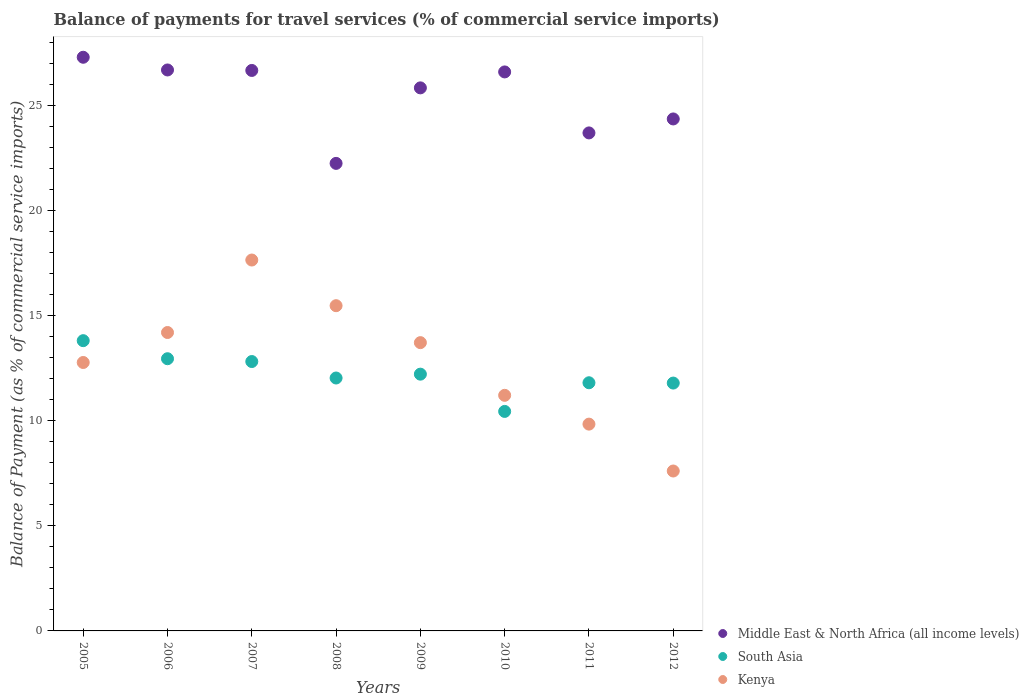What is the balance of payments for travel services in Kenya in 2011?
Offer a very short reply. 9.84. Across all years, what is the maximum balance of payments for travel services in Kenya?
Offer a terse response. 17.65. Across all years, what is the minimum balance of payments for travel services in South Asia?
Your response must be concise. 10.45. In which year was the balance of payments for travel services in South Asia minimum?
Give a very brief answer. 2010. What is the total balance of payments for travel services in Middle East & North Africa (all income levels) in the graph?
Offer a very short reply. 203.42. What is the difference between the balance of payments for travel services in Middle East & North Africa (all income levels) in 2005 and that in 2009?
Keep it short and to the point. 1.46. What is the difference between the balance of payments for travel services in Middle East & North Africa (all income levels) in 2008 and the balance of payments for travel services in South Asia in 2009?
Offer a very short reply. 10.03. What is the average balance of payments for travel services in Kenya per year?
Provide a short and direct response. 12.81. In the year 2010, what is the difference between the balance of payments for travel services in South Asia and balance of payments for travel services in Kenya?
Offer a terse response. -0.77. In how many years, is the balance of payments for travel services in South Asia greater than 4 %?
Keep it short and to the point. 8. What is the ratio of the balance of payments for travel services in South Asia in 2006 to that in 2012?
Your answer should be compact. 1.1. What is the difference between the highest and the second highest balance of payments for travel services in Kenya?
Give a very brief answer. 2.17. What is the difference between the highest and the lowest balance of payments for travel services in South Asia?
Your answer should be compact. 3.37. In how many years, is the balance of payments for travel services in Kenya greater than the average balance of payments for travel services in Kenya taken over all years?
Give a very brief answer. 4. Is it the case that in every year, the sum of the balance of payments for travel services in Middle East & North Africa (all income levels) and balance of payments for travel services in Kenya  is greater than the balance of payments for travel services in South Asia?
Your answer should be very brief. Yes. Is the balance of payments for travel services in Kenya strictly greater than the balance of payments for travel services in Middle East & North Africa (all income levels) over the years?
Offer a very short reply. No. What is the difference between two consecutive major ticks on the Y-axis?
Give a very brief answer. 5. Are the values on the major ticks of Y-axis written in scientific E-notation?
Offer a very short reply. No. Does the graph contain any zero values?
Your answer should be compact. No. How many legend labels are there?
Provide a succinct answer. 3. How are the legend labels stacked?
Provide a short and direct response. Vertical. What is the title of the graph?
Offer a terse response. Balance of payments for travel services (% of commercial service imports). What is the label or title of the Y-axis?
Ensure brevity in your answer.  Balance of Payment (as % of commercial service imports). What is the Balance of Payment (as % of commercial service imports) of Middle East & North Africa (all income levels) in 2005?
Your answer should be compact. 27.3. What is the Balance of Payment (as % of commercial service imports) of South Asia in 2005?
Your response must be concise. 13.81. What is the Balance of Payment (as % of commercial service imports) in Kenya in 2005?
Provide a short and direct response. 12.77. What is the Balance of Payment (as % of commercial service imports) of Middle East & North Africa (all income levels) in 2006?
Make the answer very short. 26.69. What is the Balance of Payment (as % of commercial service imports) of South Asia in 2006?
Your answer should be very brief. 12.95. What is the Balance of Payment (as % of commercial service imports) in Kenya in 2006?
Your answer should be very brief. 14.2. What is the Balance of Payment (as % of commercial service imports) in Middle East & North Africa (all income levels) in 2007?
Provide a short and direct response. 26.67. What is the Balance of Payment (as % of commercial service imports) of South Asia in 2007?
Provide a short and direct response. 12.82. What is the Balance of Payment (as % of commercial service imports) in Kenya in 2007?
Your answer should be very brief. 17.65. What is the Balance of Payment (as % of commercial service imports) in Middle East & North Africa (all income levels) in 2008?
Offer a terse response. 22.25. What is the Balance of Payment (as % of commercial service imports) in South Asia in 2008?
Your answer should be very brief. 12.04. What is the Balance of Payment (as % of commercial service imports) in Kenya in 2008?
Provide a succinct answer. 15.48. What is the Balance of Payment (as % of commercial service imports) of Middle East & North Africa (all income levels) in 2009?
Your response must be concise. 25.84. What is the Balance of Payment (as % of commercial service imports) of South Asia in 2009?
Keep it short and to the point. 12.22. What is the Balance of Payment (as % of commercial service imports) of Kenya in 2009?
Give a very brief answer. 13.72. What is the Balance of Payment (as % of commercial service imports) of Middle East & North Africa (all income levels) in 2010?
Provide a succinct answer. 26.6. What is the Balance of Payment (as % of commercial service imports) in South Asia in 2010?
Provide a short and direct response. 10.45. What is the Balance of Payment (as % of commercial service imports) in Kenya in 2010?
Offer a terse response. 11.21. What is the Balance of Payment (as % of commercial service imports) in Middle East & North Africa (all income levels) in 2011?
Keep it short and to the point. 23.7. What is the Balance of Payment (as % of commercial service imports) in South Asia in 2011?
Keep it short and to the point. 11.81. What is the Balance of Payment (as % of commercial service imports) in Kenya in 2011?
Give a very brief answer. 9.84. What is the Balance of Payment (as % of commercial service imports) in Middle East & North Africa (all income levels) in 2012?
Your answer should be compact. 24.36. What is the Balance of Payment (as % of commercial service imports) in South Asia in 2012?
Give a very brief answer. 11.79. What is the Balance of Payment (as % of commercial service imports) of Kenya in 2012?
Provide a succinct answer. 7.61. Across all years, what is the maximum Balance of Payment (as % of commercial service imports) of Middle East & North Africa (all income levels)?
Your response must be concise. 27.3. Across all years, what is the maximum Balance of Payment (as % of commercial service imports) in South Asia?
Your answer should be very brief. 13.81. Across all years, what is the maximum Balance of Payment (as % of commercial service imports) of Kenya?
Keep it short and to the point. 17.65. Across all years, what is the minimum Balance of Payment (as % of commercial service imports) in Middle East & North Africa (all income levels)?
Provide a short and direct response. 22.25. Across all years, what is the minimum Balance of Payment (as % of commercial service imports) in South Asia?
Ensure brevity in your answer.  10.45. Across all years, what is the minimum Balance of Payment (as % of commercial service imports) of Kenya?
Ensure brevity in your answer.  7.61. What is the total Balance of Payment (as % of commercial service imports) of Middle East & North Africa (all income levels) in the graph?
Your answer should be very brief. 203.42. What is the total Balance of Payment (as % of commercial service imports) of South Asia in the graph?
Offer a very short reply. 97.89. What is the total Balance of Payment (as % of commercial service imports) of Kenya in the graph?
Provide a short and direct response. 102.48. What is the difference between the Balance of Payment (as % of commercial service imports) in Middle East & North Africa (all income levels) in 2005 and that in 2006?
Offer a very short reply. 0.6. What is the difference between the Balance of Payment (as % of commercial service imports) of South Asia in 2005 and that in 2006?
Provide a succinct answer. 0.86. What is the difference between the Balance of Payment (as % of commercial service imports) of Kenya in 2005 and that in 2006?
Give a very brief answer. -1.43. What is the difference between the Balance of Payment (as % of commercial service imports) of Middle East & North Africa (all income levels) in 2005 and that in 2007?
Offer a very short reply. 0.63. What is the difference between the Balance of Payment (as % of commercial service imports) in South Asia in 2005 and that in 2007?
Provide a succinct answer. 0.99. What is the difference between the Balance of Payment (as % of commercial service imports) of Kenya in 2005 and that in 2007?
Provide a short and direct response. -4.88. What is the difference between the Balance of Payment (as % of commercial service imports) of Middle East & North Africa (all income levels) in 2005 and that in 2008?
Provide a succinct answer. 5.05. What is the difference between the Balance of Payment (as % of commercial service imports) in South Asia in 2005 and that in 2008?
Ensure brevity in your answer.  1.78. What is the difference between the Balance of Payment (as % of commercial service imports) of Kenya in 2005 and that in 2008?
Offer a terse response. -2.7. What is the difference between the Balance of Payment (as % of commercial service imports) in Middle East & North Africa (all income levels) in 2005 and that in 2009?
Offer a very short reply. 1.46. What is the difference between the Balance of Payment (as % of commercial service imports) in South Asia in 2005 and that in 2009?
Provide a short and direct response. 1.59. What is the difference between the Balance of Payment (as % of commercial service imports) in Kenya in 2005 and that in 2009?
Ensure brevity in your answer.  -0.94. What is the difference between the Balance of Payment (as % of commercial service imports) of Middle East & North Africa (all income levels) in 2005 and that in 2010?
Provide a succinct answer. 0.7. What is the difference between the Balance of Payment (as % of commercial service imports) of South Asia in 2005 and that in 2010?
Provide a succinct answer. 3.37. What is the difference between the Balance of Payment (as % of commercial service imports) of Kenya in 2005 and that in 2010?
Provide a short and direct response. 1.56. What is the difference between the Balance of Payment (as % of commercial service imports) in Middle East & North Africa (all income levels) in 2005 and that in 2011?
Keep it short and to the point. 3.6. What is the difference between the Balance of Payment (as % of commercial service imports) of South Asia in 2005 and that in 2011?
Ensure brevity in your answer.  2. What is the difference between the Balance of Payment (as % of commercial service imports) in Kenya in 2005 and that in 2011?
Ensure brevity in your answer.  2.93. What is the difference between the Balance of Payment (as % of commercial service imports) of Middle East & North Africa (all income levels) in 2005 and that in 2012?
Offer a very short reply. 2.94. What is the difference between the Balance of Payment (as % of commercial service imports) in South Asia in 2005 and that in 2012?
Give a very brief answer. 2.02. What is the difference between the Balance of Payment (as % of commercial service imports) of Kenya in 2005 and that in 2012?
Your answer should be very brief. 5.16. What is the difference between the Balance of Payment (as % of commercial service imports) in Middle East & North Africa (all income levels) in 2006 and that in 2007?
Provide a short and direct response. 0.02. What is the difference between the Balance of Payment (as % of commercial service imports) in South Asia in 2006 and that in 2007?
Your answer should be very brief. 0.13. What is the difference between the Balance of Payment (as % of commercial service imports) in Kenya in 2006 and that in 2007?
Your response must be concise. -3.45. What is the difference between the Balance of Payment (as % of commercial service imports) of Middle East & North Africa (all income levels) in 2006 and that in 2008?
Make the answer very short. 4.45. What is the difference between the Balance of Payment (as % of commercial service imports) in South Asia in 2006 and that in 2008?
Offer a terse response. 0.92. What is the difference between the Balance of Payment (as % of commercial service imports) in Kenya in 2006 and that in 2008?
Your response must be concise. -1.28. What is the difference between the Balance of Payment (as % of commercial service imports) of Middle East & North Africa (all income levels) in 2006 and that in 2009?
Your answer should be compact. 0.85. What is the difference between the Balance of Payment (as % of commercial service imports) of South Asia in 2006 and that in 2009?
Give a very brief answer. 0.73. What is the difference between the Balance of Payment (as % of commercial service imports) in Kenya in 2006 and that in 2009?
Keep it short and to the point. 0.48. What is the difference between the Balance of Payment (as % of commercial service imports) in Middle East & North Africa (all income levels) in 2006 and that in 2010?
Your response must be concise. 0.09. What is the difference between the Balance of Payment (as % of commercial service imports) in South Asia in 2006 and that in 2010?
Your answer should be compact. 2.51. What is the difference between the Balance of Payment (as % of commercial service imports) in Kenya in 2006 and that in 2010?
Offer a very short reply. 2.99. What is the difference between the Balance of Payment (as % of commercial service imports) in Middle East & North Africa (all income levels) in 2006 and that in 2011?
Your answer should be compact. 3. What is the difference between the Balance of Payment (as % of commercial service imports) of South Asia in 2006 and that in 2011?
Keep it short and to the point. 1.14. What is the difference between the Balance of Payment (as % of commercial service imports) in Kenya in 2006 and that in 2011?
Make the answer very short. 4.36. What is the difference between the Balance of Payment (as % of commercial service imports) of Middle East & North Africa (all income levels) in 2006 and that in 2012?
Give a very brief answer. 2.33. What is the difference between the Balance of Payment (as % of commercial service imports) of South Asia in 2006 and that in 2012?
Offer a very short reply. 1.16. What is the difference between the Balance of Payment (as % of commercial service imports) in Kenya in 2006 and that in 2012?
Offer a terse response. 6.59. What is the difference between the Balance of Payment (as % of commercial service imports) in Middle East & North Africa (all income levels) in 2007 and that in 2008?
Your answer should be compact. 4.42. What is the difference between the Balance of Payment (as % of commercial service imports) of South Asia in 2007 and that in 2008?
Your answer should be compact. 0.78. What is the difference between the Balance of Payment (as % of commercial service imports) of Kenya in 2007 and that in 2008?
Provide a short and direct response. 2.17. What is the difference between the Balance of Payment (as % of commercial service imports) in Middle East & North Africa (all income levels) in 2007 and that in 2009?
Your response must be concise. 0.83. What is the difference between the Balance of Payment (as % of commercial service imports) of South Asia in 2007 and that in 2009?
Give a very brief answer. 0.6. What is the difference between the Balance of Payment (as % of commercial service imports) in Kenya in 2007 and that in 2009?
Your answer should be compact. 3.93. What is the difference between the Balance of Payment (as % of commercial service imports) of Middle East & North Africa (all income levels) in 2007 and that in 2010?
Your answer should be compact. 0.07. What is the difference between the Balance of Payment (as % of commercial service imports) in South Asia in 2007 and that in 2010?
Give a very brief answer. 2.37. What is the difference between the Balance of Payment (as % of commercial service imports) of Kenya in 2007 and that in 2010?
Keep it short and to the point. 6.44. What is the difference between the Balance of Payment (as % of commercial service imports) of Middle East & North Africa (all income levels) in 2007 and that in 2011?
Your answer should be compact. 2.97. What is the difference between the Balance of Payment (as % of commercial service imports) in South Asia in 2007 and that in 2011?
Ensure brevity in your answer.  1.01. What is the difference between the Balance of Payment (as % of commercial service imports) of Kenya in 2007 and that in 2011?
Provide a short and direct response. 7.81. What is the difference between the Balance of Payment (as % of commercial service imports) in Middle East & North Africa (all income levels) in 2007 and that in 2012?
Ensure brevity in your answer.  2.31. What is the difference between the Balance of Payment (as % of commercial service imports) in South Asia in 2007 and that in 2012?
Ensure brevity in your answer.  1.02. What is the difference between the Balance of Payment (as % of commercial service imports) of Kenya in 2007 and that in 2012?
Give a very brief answer. 10.04. What is the difference between the Balance of Payment (as % of commercial service imports) in Middle East & North Africa (all income levels) in 2008 and that in 2009?
Provide a short and direct response. -3.59. What is the difference between the Balance of Payment (as % of commercial service imports) of South Asia in 2008 and that in 2009?
Give a very brief answer. -0.18. What is the difference between the Balance of Payment (as % of commercial service imports) in Kenya in 2008 and that in 2009?
Your response must be concise. 1.76. What is the difference between the Balance of Payment (as % of commercial service imports) of Middle East & North Africa (all income levels) in 2008 and that in 2010?
Ensure brevity in your answer.  -4.35. What is the difference between the Balance of Payment (as % of commercial service imports) in South Asia in 2008 and that in 2010?
Keep it short and to the point. 1.59. What is the difference between the Balance of Payment (as % of commercial service imports) in Kenya in 2008 and that in 2010?
Provide a short and direct response. 4.27. What is the difference between the Balance of Payment (as % of commercial service imports) in Middle East & North Africa (all income levels) in 2008 and that in 2011?
Offer a terse response. -1.45. What is the difference between the Balance of Payment (as % of commercial service imports) of South Asia in 2008 and that in 2011?
Ensure brevity in your answer.  0.23. What is the difference between the Balance of Payment (as % of commercial service imports) of Kenya in 2008 and that in 2011?
Your answer should be very brief. 5.64. What is the difference between the Balance of Payment (as % of commercial service imports) in Middle East & North Africa (all income levels) in 2008 and that in 2012?
Provide a succinct answer. -2.11. What is the difference between the Balance of Payment (as % of commercial service imports) in South Asia in 2008 and that in 2012?
Offer a terse response. 0.24. What is the difference between the Balance of Payment (as % of commercial service imports) of Kenya in 2008 and that in 2012?
Offer a terse response. 7.87. What is the difference between the Balance of Payment (as % of commercial service imports) in Middle East & North Africa (all income levels) in 2009 and that in 2010?
Make the answer very short. -0.76. What is the difference between the Balance of Payment (as % of commercial service imports) of South Asia in 2009 and that in 2010?
Your answer should be very brief. 1.77. What is the difference between the Balance of Payment (as % of commercial service imports) in Kenya in 2009 and that in 2010?
Provide a succinct answer. 2.51. What is the difference between the Balance of Payment (as % of commercial service imports) in Middle East & North Africa (all income levels) in 2009 and that in 2011?
Make the answer very short. 2.14. What is the difference between the Balance of Payment (as % of commercial service imports) in South Asia in 2009 and that in 2011?
Provide a succinct answer. 0.41. What is the difference between the Balance of Payment (as % of commercial service imports) in Kenya in 2009 and that in 2011?
Ensure brevity in your answer.  3.88. What is the difference between the Balance of Payment (as % of commercial service imports) in Middle East & North Africa (all income levels) in 2009 and that in 2012?
Keep it short and to the point. 1.48. What is the difference between the Balance of Payment (as % of commercial service imports) in South Asia in 2009 and that in 2012?
Ensure brevity in your answer.  0.42. What is the difference between the Balance of Payment (as % of commercial service imports) of Kenya in 2009 and that in 2012?
Your response must be concise. 6.11. What is the difference between the Balance of Payment (as % of commercial service imports) in Middle East & North Africa (all income levels) in 2010 and that in 2011?
Provide a succinct answer. 2.9. What is the difference between the Balance of Payment (as % of commercial service imports) in South Asia in 2010 and that in 2011?
Offer a very short reply. -1.36. What is the difference between the Balance of Payment (as % of commercial service imports) in Kenya in 2010 and that in 2011?
Your answer should be very brief. 1.37. What is the difference between the Balance of Payment (as % of commercial service imports) of Middle East & North Africa (all income levels) in 2010 and that in 2012?
Keep it short and to the point. 2.24. What is the difference between the Balance of Payment (as % of commercial service imports) of South Asia in 2010 and that in 2012?
Ensure brevity in your answer.  -1.35. What is the difference between the Balance of Payment (as % of commercial service imports) in Kenya in 2010 and that in 2012?
Your response must be concise. 3.6. What is the difference between the Balance of Payment (as % of commercial service imports) in Middle East & North Africa (all income levels) in 2011 and that in 2012?
Provide a short and direct response. -0.66. What is the difference between the Balance of Payment (as % of commercial service imports) of South Asia in 2011 and that in 2012?
Your answer should be compact. 0.01. What is the difference between the Balance of Payment (as % of commercial service imports) of Kenya in 2011 and that in 2012?
Your answer should be compact. 2.23. What is the difference between the Balance of Payment (as % of commercial service imports) of Middle East & North Africa (all income levels) in 2005 and the Balance of Payment (as % of commercial service imports) of South Asia in 2006?
Offer a very short reply. 14.35. What is the difference between the Balance of Payment (as % of commercial service imports) of Middle East & North Africa (all income levels) in 2005 and the Balance of Payment (as % of commercial service imports) of Kenya in 2006?
Your answer should be compact. 13.1. What is the difference between the Balance of Payment (as % of commercial service imports) in South Asia in 2005 and the Balance of Payment (as % of commercial service imports) in Kenya in 2006?
Ensure brevity in your answer.  -0.39. What is the difference between the Balance of Payment (as % of commercial service imports) in Middle East & North Africa (all income levels) in 2005 and the Balance of Payment (as % of commercial service imports) in South Asia in 2007?
Ensure brevity in your answer.  14.48. What is the difference between the Balance of Payment (as % of commercial service imports) in Middle East & North Africa (all income levels) in 2005 and the Balance of Payment (as % of commercial service imports) in Kenya in 2007?
Your response must be concise. 9.65. What is the difference between the Balance of Payment (as % of commercial service imports) in South Asia in 2005 and the Balance of Payment (as % of commercial service imports) in Kenya in 2007?
Provide a succinct answer. -3.84. What is the difference between the Balance of Payment (as % of commercial service imports) of Middle East & North Africa (all income levels) in 2005 and the Balance of Payment (as % of commercial service imports) of South Asia in 2008?
Give a very brief answer. 15.26. What is the difference between the Balance of Payment (as % of commercial service imports) in Middle East & North Africa (all income levels) in 2005 and the Balance of Payment (as % of commercial service imports) in Kenya in 2008?
Provide a succinct answer. 11.82. What is the difference between the Balance of Payment (as % of commercial service imports) in South Asia in 2005 and the Balance of Payment (as % of commercial service imports) in Kenya in 2008?
Provide a short and direct response. -1.66. What is the difference between the Balance of Payment (as % of commercial service imports) in Middle East & North Africa (all income levels) in 2005 and the Balance of Payment (as % of commercial service imports) in South Asia in 2009?
Give a very brief answer. 15.08. What is the difference between the Balance of Payment (as % of commercial service imports) in Middle East & North Africa (all income levels) in 2005 and the Balance of Payment (as % of commercial service imports) in Kenya in 2009?
Your response must be concise. 13.58. What is the difference between the Balance of Payment (as % of commercial service imports) in South Asia in 2005 and the Balance of Payment (as % of commercial service imports) in Kenya in 2009?
Offer a terse response. 0.09. What is the difference between the Balance of Payment (as % of commercial service imports) in Middle East & North Africa (all income levels) in 2005 and the Balance of Payment (as % of commercial service imports) in South Asia in 2010?
Provide a succinct answer. 16.85. What is the difference between the Balance of Payment (as % of commercial service imports) in Middle East & North Africa (all income levels) in 2005 and the Balance of Payment (as % of commercial service imports) in Kenya in 2010?
Your response must be concise. 16.09. What is the difference between the Balance of Payment (as % of commercial service imports) of South Asia in 2005 and the Balance of Payment (as % of commercial service imports) of Kenya in 2010?
Your answer should be very brief. 2.6. What is the difference between the Balance of Payment (as % of commercial service imports) of Middle East & North Africa (all income levels) in 2005 and the Balance of Payment (as % of commercial service imports) of South Asia in 2011?
Make the answer very short. 15.49. What is the difference between the Balance of Payment (as % of commercial service imports) in Middle East & North Africa (all income levels) in 2005 and the Balance of Payment (as % of commercial service imports) in Kenya in 2011?
Give a very brief answer. 17.46. What is the difference between the Balance of Payment (as % of commercial service imports) in South Asia in 2005 and the Balance of Payment (as % of commercial service imports) in Kenya in 2011?
Provide a succinct answer. 3.97. What is the difference between the Balance of Payment (as % of commercial service imports) in Middle East & North Africa (all income levels) in 2005 and the Balance of Payment (as % of commercial service imports) in South Asia in 2012?
Offer a terse response. 15.5. What is the difference between the Balance of Payment (as % of commercial service imports) of Middle East & North Africa (all income levels) in 2005 and the Balance of Payment (as % of commercial service imports) of Kenya in 2012?
Provide a short and direct response. 19.69. What is the difference between the Balance of Payment (as % of commercial service imports) of South Asia in 2005 and the Balance of Payment (as % of commercial service imports) of Kenya in 2012?
Keep it short and to the point. 6.2. What is the difference between the Balance of Payment (as % of commercial service imports) in Middle East & North Africa (all income levels) in 2006 and the Balance of Payment (as % of commercial service imports) in South Asia in 2007?
Provide a succinct answer. 13.88. What is the difference between the Balance of Payment (as % of commercial service imports) of Middle East & North Africa (all income levels) in 2006 and the Balance of Payment (as % of commercial service imports) of Kenya in 2007?
Ensure brevity in your answer.  9.04. What is the difference between the Balance of Payment (as % of commercial service imports) of South Asia in 2006 and the Balance of Payment (as % of commercial service imports) of Kenya in 2007?
Provide a short and direct response. -4.7. What is the difference between the Balance of Payment (as % of commercial service imports) of Middle East & North Africa (all income levels) in 2006 and the Balance of Payment (as % of commercial service imports) of South Asia in 2008?
Make the answer very short. 14.66. What is the difference between the Balance of Payment (as % of commercial service imports) in Middle East & North Africa (all income levels) in 2006 and the Balance of Payment (as % of commercial service imports) in Kenya in 2008?
Provide a succinct answer. 11.22. What is the difference between the Balance of Payment (as % of commercial service imports) of South Asia in 2006 and the Balance of Payment (as % of commercial service imports) of Kenya in 2008?
Give a very brief answer. -2.52. What is the difference between the Balance of Payment (as % of commercial service imports) of Middle East & North Africa (all income levels) in 2006 and the Balance of Payment (as % of commercial service imports) of South Asia in 2009?
Offer a terse response. 14.48. What is the difference between the Balance of Payment (as % of commercial service imports) in Middle East & North Africa (all income levels) in 2006 and the Balance of Payment (as % of commercial service imports) in Kenya in 2009?
Your answer should be very brief. 12.98. What is the difference between the Balance of Payment (as % of commercial service imports) of South Asia in 2006 and the Balance of Payment (as % of commercial service imports) of Kenya in 2009?
Offer a terse response. -0.77. What is the difference between the Balance of Payment (as % of commercial service imports) of Middle East & North Africa (all income levels) in 2006 and the Balance of Payment (as % of commercial service imports) of South Asia in 2010?
Make the answer very short. 16.25. What is the difference between the Balance of Payment (as % of commercial service imports) in Middle East & North Africa (all income levels) in 2006 and the Balance of Payment (as % of commercial service imports) in Kenya in 2010?
Offer a very short reply. 15.48. What is the difference between the Balance of Payment (as % of commercial service imports) in South Asia in 2006 and the Balance of Payment (as % of commercial service imports) in Kenya in 2010?
Make the answer very short. 1.74. What is the difference between the Balance of Payment (as % of commercial service imports) in Middle East & North Africa (all income levels) in 2006 and the Balance of Payment (as % of commercial service imports) in South Asia in 2011?
Offer a terse response. 14.88. What is the difference between the Balance of Payment (as % of commercial service imports) of Middle East & North Africa (all income levels) in 2006 and the Balance of Payment (as % of commercial service imports) of Kenya in 2011?
Your answer should be very brief. 16.85. What is the difference between the Balance of Payment (as % of commercial service imports) in South Asia in 2006 and the Balance of Payment (as % of commercial service imports) in Kenya in 2011?
Your response must be concise. 3.11. What is the difference between the Balance of Payment (as % of commercial service imports) of Middle East & North Africa (all income levels) in 2006 and the Balance of Payment (as % of commercial service imports) of South Asia in 2012?
Keep it short and to the point. 14.9. What is the difference between the Balance of Payment (as % of commercial service imports) of Middle East & North Africa (all income levels) in 2006 and the Balance of Payment (as % of commercial service imports) of Kenya in 2012?
Keep it short and to the point. 19.08. What is the difference between the Balance of Payment (as % of commercial service imports) of South Asia in 2006 and the Balance of Payment (as % of commercial service imports) of Kenya in 2012?
Your answer should be very brief. 5.34. What is the difference between the Balance of Payment (as % of commercial service imports) of Middle East & North Africa (all income levels) in 2007 and the Balance of Payment (as % of commercial service imports) of South Asia in 2008?
Give a very brief answer. 14.64. What is the difference between the Balance of Payment (as % of commercial service imports) of Middle East & North Africa (all income levels) in 2007 and the Balance of Payment (as % of commercial service imports) of Kenya in 2008?
Make the answer very short. 11.19. What is the difference between the Balance of Payment (as % of commercial service imports) of South Asia in 2007 and the Balance of Payment (as % of commercial service imports) of Kenya in 2008?
Make the answer very short. -2.66. What is the difference between the Balance of Payment (as % of commercial service imports) of Middle East & North Africa (all income levels) in 2007 and the Balance of Payment (as % of commercial service imports) of South Asia in 2009?
Make the answer very short. 14.45. What is the difference between the Balance of Payment (as % of commercial service imports) of Middle East & North Africa (all income levels) in 2007 and the Balance of Payment (as % of commercial service imports) of Kenya in 2009?
Give a very brief answer. 12.95. What is the difference between the Balance of Payment (as % of commercial service imports) in South Asia in 2007 and the Balance of Payment (as % of commercial service imports) in Kenya in 2009?
Offer a terse response. -0.9. What is the difference between the Balance of Payment (as % of commercial service imports) in Middle East & North Africa (all income levels) in 2007 and the Balance of Payment (as % of commercial service imports) in South Asia in 2010?
Your answer should be compact. 16.23. What is the difference between the Balance of Payment (as % of commercial service imports) of Middle East & North Africa (all income levels) in 2007 and the Balance of Payment (as % of commercial service imports) of Kenya in 2010?
Provide a short and direct response. 15.46. What is the difference between the Balance of Payment (as % of commercial service imports) in South Asia in 2007 and the Balance of Payment (as % of commercial service imports) in Kenya in 2010?
Give a very brief answer. 1.61. What is the difference between the Balance of Payment (as % of commercial service imports) in Middle East & North Africa (all income levels) in 2007 and the Balance of Payment (as % of commercial service imports) in South Asia in 2011?
Offer a terse response. 14.86. What is the difference between the Balance of Payment (as % of commercial service imports) of Middle East & North Africa (all income levels) in 2007 and the Balance of Payment (as % of commercial service imports) of Kenya in 2011?
Provide a succinct answer. 16.83. What is the difference between the Balance of Payment (as % of commercial service imports) of South Asia in 2007 and the Balance of Payment (as % of commercial service imports) of Kenya in 2011?
Your response must be concise. 2.98. What is the difference between the Balance of Payment (as % of commercial service imports) in Middle East & North Africa (all income levels) in 2007 and the Balance of Payment (as % of commercial service imports) in South Asia in 2012?
Your response must be concise. 14.88. What is the difference between the Balance of Payment (as % of commercial service imports) of Middle East & North Africa (all income levels) in 2007 and the Balance of Payment (as % of commercial service imports) of Kenya in 2012?
Your answer should be compact. 19.06. What is the difference between the Balance of Payment (as % of commercial service imports) of South Asia in 2007 and the Balance of Payment (as % of commercial service imports) of Kenya in 2012?
Provide a succinct answer. 5.21. What is the difference between the Balance of Payment (as % of commercial service imports) of Middle East & North Africa (all income levels) in 2008 and the Balance of Payment (as % of commercial service imports) of South Asia in 2009?
Your answer should be very brief. 10.03. What is the difference between the Balance of Payment (as % of commercial service imports) of Middle East & North Africa (all income levels) in 2008 and the Balance of Payment (as % of commercial service imports) of Kenya in 2009?
Provide a succinct answer. 8.53. What is the difference between the Balance of Payment (as % of commercial service imports) in South Asia in 2008 and the Balance of Payment (as % of commercial service imports) in Kenya in 2009?
Provide a succinct answer. -1.68. What is the difference between the Balance of Payment (as % of commercial service imports) of Middle East & North Africa (all income levels) in 2008 and the Balance of Payment (as % of commercial service imports) of South Asia in 2010?
Offer a very short reply. 11.8. What is the difference between the Balance of Payment (as % of commercial service imports) in Middle East & North Africa (all income levels) in 2008 and the Balance of Payment (as % of commercial service imports) in Kenya in 2010?
Offer a very short reply. 11.04. What is the difference between the Balance of Payment (as % of commercial service imports) of South Asia in 2008 and the Balance of Payment (as % of commercial service imports) of Kenya in 2010?
Offer a very short reply. 0.82. What is the difference between the Balance of Payment (as % of commercial service imports) of Middle East & North Africa (all income levels) in 2008 and the Balance of Payment (as % of commercial service imports) of South Asia in 2011?
Your response must be concise. 10.44. What is the difference between the Balance of Payment (as % of commercial service imports) of Middle East & North Africa (all income levels) in 2008 and the Balance of Payment (as % of commercial service imports) of Kenya in 2011?
Your answer should be very brief. 12.41. What is the difference between the Balance of Payment (as % of commercial service imports) in South Asia in 2008 and the Balance of Payment (as % of commercial service imports) in Kenya in 2011?
Offer a very short reply. 2.19. What is the difference between the Balance of Payment (as % of commercial service imports) in Middle East & North Africa (all income levels) in 2008 and the Balance of Payment (as % of commercial service imports) in South Asia in 2012?
Offer a terse response. 10.45. What is the difference between the Balance of Payment (as % of commercial service imports) of Middle East & North Africa (all income levels) in 2008 and the Balance of Payment (as % of commercial service imports) of Kenya in 2012?
Ensure brevity in your answer.  14.64. What is the difference between the Balance of Payment (as % of commercial service imports) in South Asia in 2008 and the Balance of Payment (as % of commercial service imports) in Kenya in 2012?
Your answer should be very brief. 4.43. What is the difference between the Balance of Payment (as % of commercial service imports) in Middle East & North Africa (all income levels) in 2009 and the Balance of Payment (as % of commercial service imports) in South Asia in 2010?
Your answer should be very brief. 15.4. What is the difference between the Balance of Payment (as % of commercial service imports) of Middle East & North Africa (all income levels) in 2009 and the Balance of Payment (as % of commercial service imports) of Kenya in 2010?
Your answer should be compact. 14.63. What is the difference between the Balance of Payment (as % of commercial service imports) of South Asia in 2009 and the Balance of Payment (as % of commercial service imports) of Kenya in 2010?
Ensure brevity in your answer.  1.01. What is the difference between the Balance of Payment (as % of commercial service imports) in Middle East & North Africa (all income levels) in 2009 and the Balance of Payment (as % of commercial service imports) in South Asia in 2011?
Your response must be concise. 14.03. What is the difference between the Balance of Payment (as % of commercial service imports) of Middle East & North Africa (all income levels) in 2009 and the Balance of Payment (as % of commercial service imports) of Kenya in 2011?
Offer a terse response. 16. What is the difference between the Balance of Payment (as % of commercial service imports) in South Asia in 2009 and the Balance of Payment (as % of commercial service imports) in Kenya in 2011?
Your response must be concise. 2.38. What is the difference between the Balance of Payment (as % of commercial service imports) in Middle East & North Africa (all income levels) in 2009 and the Balance of Payment (as % of commercial service imports) in South Asia in 2012?
Make the answer very short. 14.05. What is the difference between the Balance of Payment (as % of commercial service imports) of Middle East & North Africa (all income levels) in 2009 and the Balance of Payment (as % of commercial service imports) of Kenya in 2012?
Give a very brief answer. 18.23. What is the difference between the Balance of Payment (as % of commercial service imports) in South Asia in 2009 and the Balance of Payment (as % of commercial service imports) in Kenya in 2012?
Give a very brief answer. 4.61. What is the difference between the Balance of Payment (as % of commercial service imports) of Middle East & North Africa (all income levels) in 2010 and the Balance of Payment (as % of commercial service imports) of South Asia in 2011?
Keep it short and to the point. 14.79. What is the difference between the Balance of Payment (as % of commercial service imports) of Middle East & North Africa (all income levels) in 2010 and the Balance of Payment (as % of commercial service imports) of Kenya in 2011?
Make the answer very short. 16.76. What is the difference between the Balance of Payment (as % of commercial service imports) in South Asia in 2010 and the Balance of Payment (as % of commercial service imports) in Kenya in 2011?
Ensure brevity in your answer.  0.6. What is the difference between the Balance of Payment (as % of commercial service imports) in Middle East & North Africa (all income levels) in 2010 and the Balance of Payment (as % of commercial service imports) in South Asia in 2012?
Offer a very short reply. 14.81. What is the difference between the Balance of Payment (as % of commercial service imports) in Middle East & North Africa (all income levels) in 2010 and the Balance of Payment (as % of commercial service imports) in Kenya in 2012?
Keep it short and to the point. 18.99. What is the difference between the Balance of Payment (as % of commercial service imports) in South Asia in 2010 and the Balance of Payment (as % of commercial service imports) in Kenya in 2012?
Provide a succinct answer. 2.84. What is the difference between the Balance of Payment (as % of commercial service imports) of Middle East & North Africa (all income levels) in 2011 and the Balance of Payment (as % of commercial service imports) of South Asia in 2012?
Your answer should be very brief. 11.9. What is the difference between the Balance of Payment (as % of commercial service imports) in Middle East & North Africa (all income levels) in 2011 and the Balance of Payment (as % of commercial service imports) in Kenya in 2012?
Provide a short and direct response. 16.09. What is the difference between the Balance of Payment (as % of commercial service imports) of South Asia in 2011 and the Balance of Payment (as % of commercial service imports) of Kenya in 2012?
Your answer should be compact. 4.2. What is the average Balance of Payment (as % of commercial service imports) of Middle East & North Africa (all income levels) per year?
Provide a succinct answer. 25.43. What is the average Balance of Payment (as % of commercial service imports) in South Asia per year?
Ensure brevity in your answer.  12.24. What is the average Balance of Payment (as % of commercial service imports) in Kenya per year?
Your response must be concise. 12.81. In the year 2005, what is the difference between the Balance of Payment (as % of commercial service imports) of Middle East & North Africa (all income levels) and Balance of Payment (as % of commercial service imports) of South Asia?
Your response must be concise. 13.49. In the year 2005, what is the difference between the Balance of Payment (as % of commercial service imports) in Middle East & North Africa (all income levels) and Balance of Payment (as % of commercial service imports) in Kenya?
Give a very brief answer. 14.52. In the year 2005, what is the difference between the Balance of Payment (as % of commercial service imports) in South Asia and Balance of Payment (as % of commercial service imports) in Kenya?
Offer a terse response. 1.04. In the year 2006, what is the difference between the Balance of Payment (as % of commercial service imports) in Middle East & North Africa (all income levels) and Balance of Payment (as % of commercial service imports) in South Asia?
Provide a succinct answer. 13.74. In the year 2006, what is the difference between the Balance of Payment (as % of commercial service imports) of Middle East & North Africa (all income levels) and Balance of Payment (as % of commercial service imports) of Kenya?
Ensure brevity in your answer.  12.49. In the year 2006, what is the difference between the Balance of Payment (as % of commercial service imports) in South Asia and Balance of Payment (as % of commercial service imports) in Kenya?
Provide a succinct answer. -1.25. In the year 2007, what is the difference between the Balance of Payment (as % of commercial service imports) of Middle East & North Africa (all income levels) and Balance of Payment (as % of commercial service imports) of South Asia?
Your response must be concise. 13.85. In the year 2007, what is the difference between the Balance of Payment (as % of commercial service imports) of Middle East & North Africa (all income levels) and Balance of Payment (as % of commercial service imports) of Kenya?
Offer a very short reply. 9.02. In the year 2007, what is the difference between the Balance of Payment (as % of commercial service imports) of South Asia and Balance of Payment (as % of commercial service imports) of Kenya?
Give a very brief answer. -4.83. In the year 2008, what is the difference between the Balance of Payment (as % of commercial service imports) in Middle East & North Africa (all income levels) and Balance of Payment (as % of commercial service imports) in South Asia?
Make the answer very short. 10.21. In the year 2008, what is the difference between the Balance of Payment (as % of commercial service imports) of Middle East & North Africa (all income levels) and Balance of Payment (as % of commercial service imports) of Kenya?
Offer a terse response. 6.77. In the year 2008, what is the difference between the Balance of Payment (as % of commercial service imports) of South Asia and Balance of Payment (as % of commercial service imports) of Kenya?
Offer a terse response. -3.44. In the year 2009, what is the difference between the Balance of Payment (as % of commercial service imports) in Middle East & North Africa (all income levels) and Balance of Payment (as % of commercial service imports) in South Asia?
Give a very brief answer. 13.62. In the year 2009, what is the difference between the Balance of Payment (as % of commercial service imports) in Middle East & North Africa (all income levels) and Balance of Payment (as % of commercial service imports) in Kenya?
Offer a very short reply. 12.12. In the year 2009, what is the difference between the Balance of Payment (as % of commercial service imports) in South Asia and Balance of Payment (as % of commercial service imports) in Kenya?
Provide a short and direct response. -1.5. In the year 2010, what is the difference between the Balance of Payment (as % of commercial service imports) in Middle East & North Africa (all income levels) and Balance of Payment (as % of commercial service imports) in South Asia?
Keep it short and to the point. 16.16. In the year 2010, what is the difference between the Balance of Payment (as % of commercial service imports) in Middle East & North Africa (all income levels) and Balance of Payment (as % of commercial service imports) in Kenya?
Your answer should be compact. 15.39. In the year 2010, what is the difference between the Balance of Payment (as % of commercial service imports) in South Asia and Balance of Payment (as % of commercial service imports) in Kenya?
Your answer should be very brief. -0.77. In the year 2011, what is the difference between the Balance of Payment (as % of commercial service imports) of Middle East & North Africa (all income levels) and Balance of Payment (as % of commercial service imports) of South Asia?
Make the answer very short. 11.89. In the year 2011, what is the difference between the Balance of Payment (as % of commercial service imports) of Middle East & North Africa (all income levels) and Balance of Payment (as % of commercial service imports) of Kenya?
Your response must be concise. 13.86. In the year 2011, what is the difference between the Balance of Payment (as % of commercial service imports) of South Asia and Balance of Payment (as % of commercial service imports) of Kenya?
Offer a terse response. 1.97. In the year 2012, what is the difference between the Balance of Payment (as % of commercial service imports) of Middle East & North Africa (all income levels) and Balance of Payment (as % of commercial service imports) of South Asia?
Keep it short and to the point. 12.57. In the year 2012, what is the difference between the Balance of Payment (as % of commercial service imports) in Middle East & North Africa (all income levels) and Balance of Payment (as % of commercial service imports) in Kenya?
Your answer should be very brief. 16.75. In the year 2012, what is the difference between the Balance of Payment (as % of commercial service imports) of South Asia and Balance of Payment (as % of commercial service imports) of Kenya?
Give a very brief answer. 4.18. What is the ratio of the Balance of Payment (as % of commercial service imports) of Middle East & North Africa (all income levels) in 2005 to that in 2006?
Keep it short and to the point. 1.02. What is the ratio of the Balance of Payment (as % of commercial service imports) of South Asia in 2005 to that in 2006?
Make the answer very short. 1.07. What is the ratio of the Balance of Payment (as % of commercial service imports) in Kenya in 2005 to that in 2006?
Make the answer very short. 0.9. What is the ratio of the Balance of Payment (as % of commercial service imports) of Middle East & North Africa (all income levels) in 2005 to that in 2007?
Your answer should be very brief. 1.02. What is the ratio of the Balance of Payment (as % of commercial service imports) of South Asia in 2005 to that in 2007?
Your answer should be compact. 1.08. What is the ratio of the Balance of Payment (as % of commercial service imports) in Kenya in 2005 to that in 2007?
Offer a terse response. 0.72. What is the ratio of the Balance of Payment (as % of commercial service imports) of Middle East & North Africa (all income levels) in 2005 to that in 2008?
Your response must be concise. 1.23. What is the ratio of the Balance of Payment (as % of commercial service imports) in South Asia in 2005 to that in 2008?
Your response must be concise. 1.15. What is the ratio of the Balance of Payment (as % of commercial service imports) of Kenya in 2005 to that in 2008?
Keep it short and to the point. 0.83. What is the ratio of the Balance of Payment (as % of commercial service imports) of Middle East & North Africa (all income levels) in 2005 to that in 2009?
Offer a very short reply. 1.06. What is the ratio of the Balance of Payment (as % of commercial service imports) of South Asia in 2005 to that in 2009?
Ensure brevity in your answer.  1.13. What is the ratio of the Balance of Payment (as % of commercial service imports) in Kenya in 2005 to that in 2009?
Make the answer very short. 0.93. What is the ratio of the Balance of Payment (as % of commercial service imports) in Middle East & North Africa (all income levels) in 2005 to that in 2010?
Provide a short and direct response. 1.03. What is the ratio of the Balance of Payment (as % of commercial service imports) in South Asia in 2005 to that in 2010?
Provide a short and direct response. 1.32. What is the ratio of the Balance of Payment (as % of commercial service imports) of Kenya in 2005 to that in 2010?
Your answer should be very brief. 1.14. What is the ratio of the Balance of Payment (as % of commercial service imports) in Middle East & North Africa (all income levels) in 2005 to that in 2011?
Give a very brief answer. 1.15. What is the ratio of the Balance of Payment (as % of commercial service imports) of South Asia in 2005 to that in 2011?
Provide a short and direct response. 1.17. What is the ratio of the Balance of Payment (as % of commercial service imports) in Kenya in 2005 to that in 2011?
Give a very brief answer. 1.3. What is the ratio of the Balance of Payment (as % of commercial service imports) in Middle East & North Africa (all income levels) in 2005 to that in 2012?
Give a very brief answer. 1.12. What is the ratio of the Balance of Payment (as % of commercial service imports) of South Asia in 2005 to that in 2012?
Ensure brevity in your answer.  1.17. What is the ratio of the Balance of Payment (as % of commercial service imports) in Kenya in 2005 to that in 2012?
Offer a terse response. 1.68. What is the ratio of the Balance of Payment (as % of commercial service imports) of Middle East & North Africa (all income levels) in 2006 to that in 2007?
Keep it short and to the point. 1. What is the ratio of the Balance of Payment (as % of commercial service imports) of South Asia in 2006 to that in 2007?
Your answer should be compact. 1.01. What is the ratio of the Balance of Payment (as % of commercial service imports) in Kenya in 2006 to that in 2007?
Your response must be concise. 0.8. What is the ratio of the Balance of Payment (as % of commercial service imports) in Middle East & North Africa (all income levels) in 2006 to that in 2008?
Your response must be concise. 1.2. What is the ratio of the Balance of Payment (as % of commercial service imports) in South Asia in 2006 to that in 2008?
Offer a very short reply. 1.08. What is the ratio of the Balance of Payment (as % of commercial service imports) in Kenya in 2006 to that in 2008?
Your answer should be very brief. 0.92. What is the ratio of the Balance of Payment (as % of commercial service imports) in Middle East & North Africa (all income levels) in 2006 to that in 2009?
Keep it short and to the point. 1.03. What is the ratio of the Balance of Payment (as % of commercial service imports) in South Asia in 2006 to that in 2009?
Provide a short and direct response. 1.06. What is the ratio of the Balance of Payment (as % of commercial service imports) in Kenya in 2006 to that in 2009?
Offer a very short reply. 1.04. What is the ratio of the Balance of Payment (as % of commercial service imports) of South Asia in 2006 to that in 2010?
Provide a succinct answer. 1.24. What is the ratio of the Balance of Payment (as % of commercial service imports) in Kenya in 2006 to that in 2010?
Give a very brief answer. 1.27. What is the ratio of the Balance of Payment (as % of commercial service imports) of Middle East & North Africa (all income levels) in 2006 to that in 2011?
Your answer should be compact. 1.13. What is the ratio of the Balance of Payment (as % of commercial service imports) of South Asia in 2006 to that in 2011?
Offer a terse response. 1.1. What is the ratio of the Balance of Payment (as % of commercial service imports) in Kenya in 2006 to that in 2011?
Keep it short and to the point. 1.44. What is the ratio of the Balance of Payment (as % of commercial service imports) in Middle East & North Africa (all income levels) in 2006 to that in 2012?
Give a very brief answer. 1.1. What is the ratio of the Balance of Payment (as % of commercial service imports) of South Asia in 2006 to that in 2012?
Your answer should be compact. 1.1. What is the ratio of the Balance of Payment (as % of commercial service imports) in Kenya in 2006 to that in 2012?
Offer a very short reply. 1.87. What is the ratio of the Balance of Payment (as % of commercial service imports) in Middle East & North Africa (all income levels) in 2007 to that in 2008?
Your answer should be very brief. 1.2. What is the ratio of the Balance of Payment (as % of commercial service imports) of South Asia in 2007 to that in 2008?
Provide a succinct answer. 1.07. What is the ratio of the Balance of Payment (as % of commercial service imports) of Kenya in 2007 to that in 2008?
Keep it short and to the point. 1.14. What is the ratio of the Balance of Payment (as % of commercial service imports) of Middle East & North Africa (all income levels) in 2007 to that in 2009?
Your response must be concise. 1.03. What is the ratio of the Balance of Payment (as % of commercial service imports) in South Asia in 2007 to that in 2009?
Offer a very short reply. 1.05. What is the ratio of the Balance of Payment (as % of commercial service imports) in Kenya in 2007 to that in 2009?
Your answer should be very brief. 1.29. What is the ratio of the Balance of Payment (as % of commercial service imports) of Middle East & North Africa (all income levels) in 2007 to that in 2010?
Make the answer very short. 1. What is the ratio of the Balance of Payment (as % of commercial service imports) in South Asia in 2007 to that in 2010?
Your answer should be compact. 1.23. What is the ratio of the Balance of Payment (as % of commercial service imports) of Kenya in 2007 to that in 2010?
Offer a terse response. 1.57. What is the ratio of the Balance of Payment (as % of commercial service imports) in Middle East & North Africa (all income levels) in 2007 to that in 2011?
Provide a short and direct response. 1.13. What is the ratio of the Balance of Payment (as % of commercial service imports) in South Asia in 2007 to that in 2011?
Offer a terse response. 1.09. What is the ratio of the Balance of Payment (as % of commercial service imports) in Kenya in 2007 to that in 2011?
Keep it short and to the point. 1.79. What is the ratio of the Balance of Payment (as % of commercial service imports) of Middle East & North Africa (all income levels) in 2007 to that in 2012?
Give a very brief answer. 1.09. What is the ratio of the Balance of Payment (as % of commercial service imports) in South Asia in 2007 to that in 2012?
Offer a very short reply. 1.09. What is the ratio of the Balance of Payment (as % of commercial service imports) of Kenya in 2007 to that in 2012?
Provide a short and direct response. 2.32. What is the ratio of the Balance of Payment (as % of commercial service imports) of Middle East & North Africa (all income levels) in 2008 to that in 2009?
Make the answer very short. 0.86. What is the ratio of the Balance of Payment (as % of commercial service imports) of Kenya in 2008 to that in 2009?
Your response must be concise. 1.13. What is the ratio of the Balance of Payment (as % of commercial service imports) of Middle East & North Africa (all income levels) in 2008 to that in 2010?
Keep it short and to the point. 0.84. What is the ratio of the Balance of Payment (as % of commercial service imports) in South Asia in 2008 to that in 2010?
Make the answer very short. 1.15. What is the ratio of the Balance of Payment (as % of commercial service imports) in Kenya in 2008 to that in 2010?
Your answer should be compact. 1.38. What is the ratio of the Balance of Payment (as % of commercial service imports) in Middle East & North Africa (all income levels) in 2008 to that in 2011?
Provide a short and direct response. 0.94. What is the ratio of the Balance of Payment (as % of commercial service imports) in South Asia in 2008 to that in 2011?
Keep it short and to the point. 1.02. What is the ratio of the Balance of Payment (as % of commercial service imports) in Kenya in 2008 to that in 2011?
Your answer should be compact. 1.57. What is the ratio of the Balance of Payment (as % of commercial service imports) in Middle East & North Africa (all income levels) in 2008 to that in 2012?
Your answer should be compact. 0.91. What is the ratio of the Balance of Payment (as % of commercial service imports) in South Asia in 2008 to that in 2012?
Ensure brevity in your answer.  1.02. What is the ratio of the Balance of Payment (as % of commercial service imports) of Kenya in 2008 to that in 2012?
Provide a succinct answer. 2.03. What is the ratio of the Balance of Payment (as % of commercial service imports) in Middle East & North Africa (all income levels) in 2009 to that in 2010?
Ensure brevity in your answer.  0.97. What is the ratio of the Balance of Payment (as % of commercial service imports) in South Asia in 2009 to that in 2010?
Ensure brevity in your answer.  1.17. What is the ratio of the Balance of Payment (as % of commercial service imports) in Kenya in 2009 to that in 2010?
Ensure brevity in your answer.  1.22. What is the ratio of the Balance of Payment (as % of commercial service imports) of Middle East & North Africa (all income levels) in 2009 to that in 2011?
Offer a very short reply. 1.09. What is the ratio of the Balance of Payment (as % of commercial service imports) of South Asia in 2009 to that in 2011?
Your response must be concise. 1.03. What is the ratio of the Balance of Payment (as % of commercial service imports) of Kenya in 2009 to that in 2011?
Your answer should be compact. 1.39. What is the ratio of the Balance of Payment (as % of commercial service imports) in Middle East & North Africa (all income levels) in 2009 to that in 2012?
Ensure brevity in your answer.  1.06. What is the ratio of the Balance of Payment (as % of commercial service imports) in South Asia in 2009 to that in 2012?
Provide a short and direct response. 1.04. What is the ratio of the Balance of Payment (as % of commercial service imports) in Kenya in 2009 to that in 2012?
Your answer should be very brief. 1.8. What is the ratio of the Balance of Payment (as % of commercial service imports) in Middle East & North Africa (all income levels) in 2010 to that in 2011?
Your answer should be compact. 1.12. What is the ratio of the Balance of Payment (as % of commercial service imports) in South Asia in 2010 to that in 2011?
Give a very brief answer. 0.88. What is the ratio of the Balance of Payment (as % of commercial service imports) of Kenya in 2010 to that in 2011?
Provide a short and direct response. 1.14. What is the ratio of the Balance of Payment (as % of commercial service imports) in Middle East & North Africa (all income levels) in 2010 to that in 2012?
Your response must be concise. 1.09. What is the ratio of the Balance of Payment (as % of commercial service imports) of South Asia in 2010 to that in 2012?
Your answer should be very brief. 0.89. What is the ratio of the Balance of Payment (as % of commercial service imports) of Kenya in 2010 to that in 2012?
Your response must be concise. 1.47. What is the ratio of the Balance of Payment (as % of commercial service imports) of Middle East & North Africa (all income levels) in 2011 to that in 2012?
Provide a short and direct response. 0.97. What is the ratio of the Balance of Payment (as % of commercial service imports) of South Asia in 2011 to that in 2012?
Your response must be concise. 1. What is the ratio of the Balance of Payment (as % of commercial service imports) in Kenya in 2011 to that in 2012?
Offer a very short reply. 1.29. What is the difference between the highest and the second highest Balance of Payment (as % of commercial service imports) of Middle East & North Africa (all income levels)?
Provide a short and direct response. 0.6. What is the difference between the highest and the second highest Balance of Payment (as % of commercial service imports) in South Asia?
Provide a short and direct response. 0.86. What is the difference between the highest and the second highest Balance of Payment (as % of commercial service imports) in Kenya?
Keep it short and to the point. 2.17. What is the difference between the highest and the lowest Balance of Payment (as % of commercial service imports) in Middle East & North Africa (all income levels)?
Your answer should be compact. 5.05. What is the difference between the highest and the lowest Balance of Payment (as % of commercial service imports) in South Asia?
Offer a very short reply. 3.37. What is the difference between the highest and the lowest Balance of Payment (as % of commercial service imports) of Kenya?
Provide a succinct answer. 10.04. 